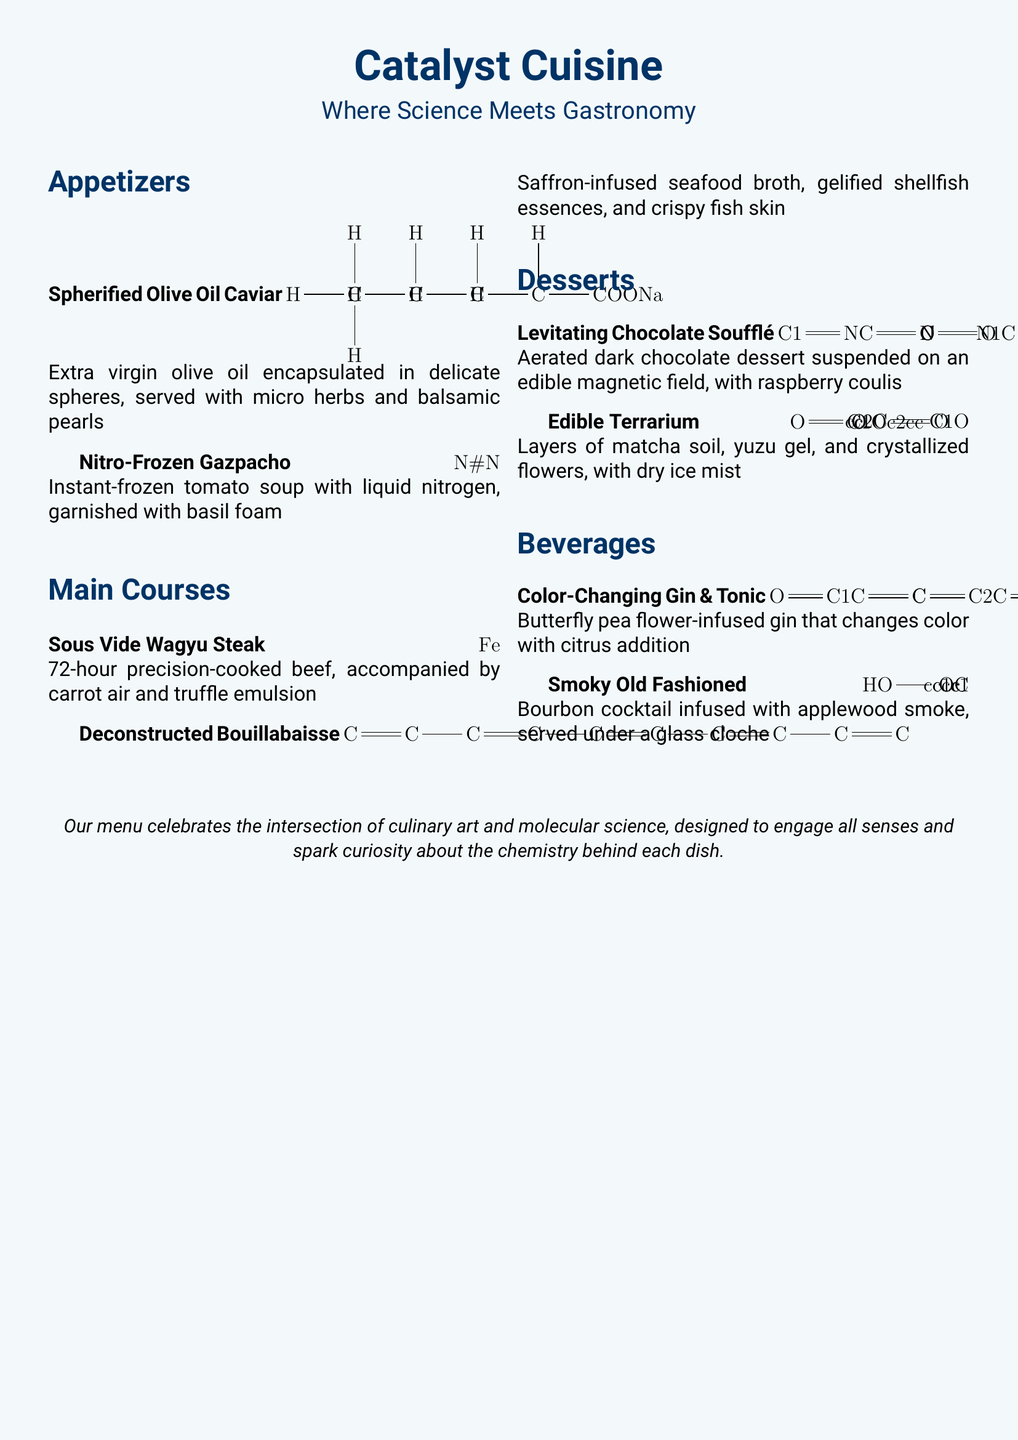what is the name of the restaurant? The name of the restaurant is prominently displayed at the top of the menu.
Answer: Catalyst Cuisine what type of cuisine does the restaurant offer? The restaurant emphasizes the combination of culinary art and molecular science.
Answer: Molecular gastronomy how many appetizers are listed on the menu? The menu lists a total of two appetizers under the Appetizers section.
Answer: 2 what is the main ingredient in the Spherified Olive Oil Caviar? The main ingredient is mentioned in the description of the dish.
Answer: Olive oil what is unique about the Levitating Chocolate Soufflé? The dish is described as suspended on an edible magnetic field, which is a unique aspect.
Answer: Edible magnetic field which beverage changes color with citrus addition? The beverage is described in the Beverages section with this specific characteristic.
Answer: Color-Changing Gin & Tonic how long is the Sous Vide Wagyu Steak cooked? The duration of the cooking method is specified in the dish description.
Answer: 72 hours what type of broth is used in the Deconstructed Bouillabaisse? The broth type is mentioned alongside its description on the menu.
Answer: Saffron-infused seafood broth what ingredient is used to infuse the Smoky Old Fashioned? The infusion ingredient is specified in the description of the beverage.
Answer: Applewood smoke 